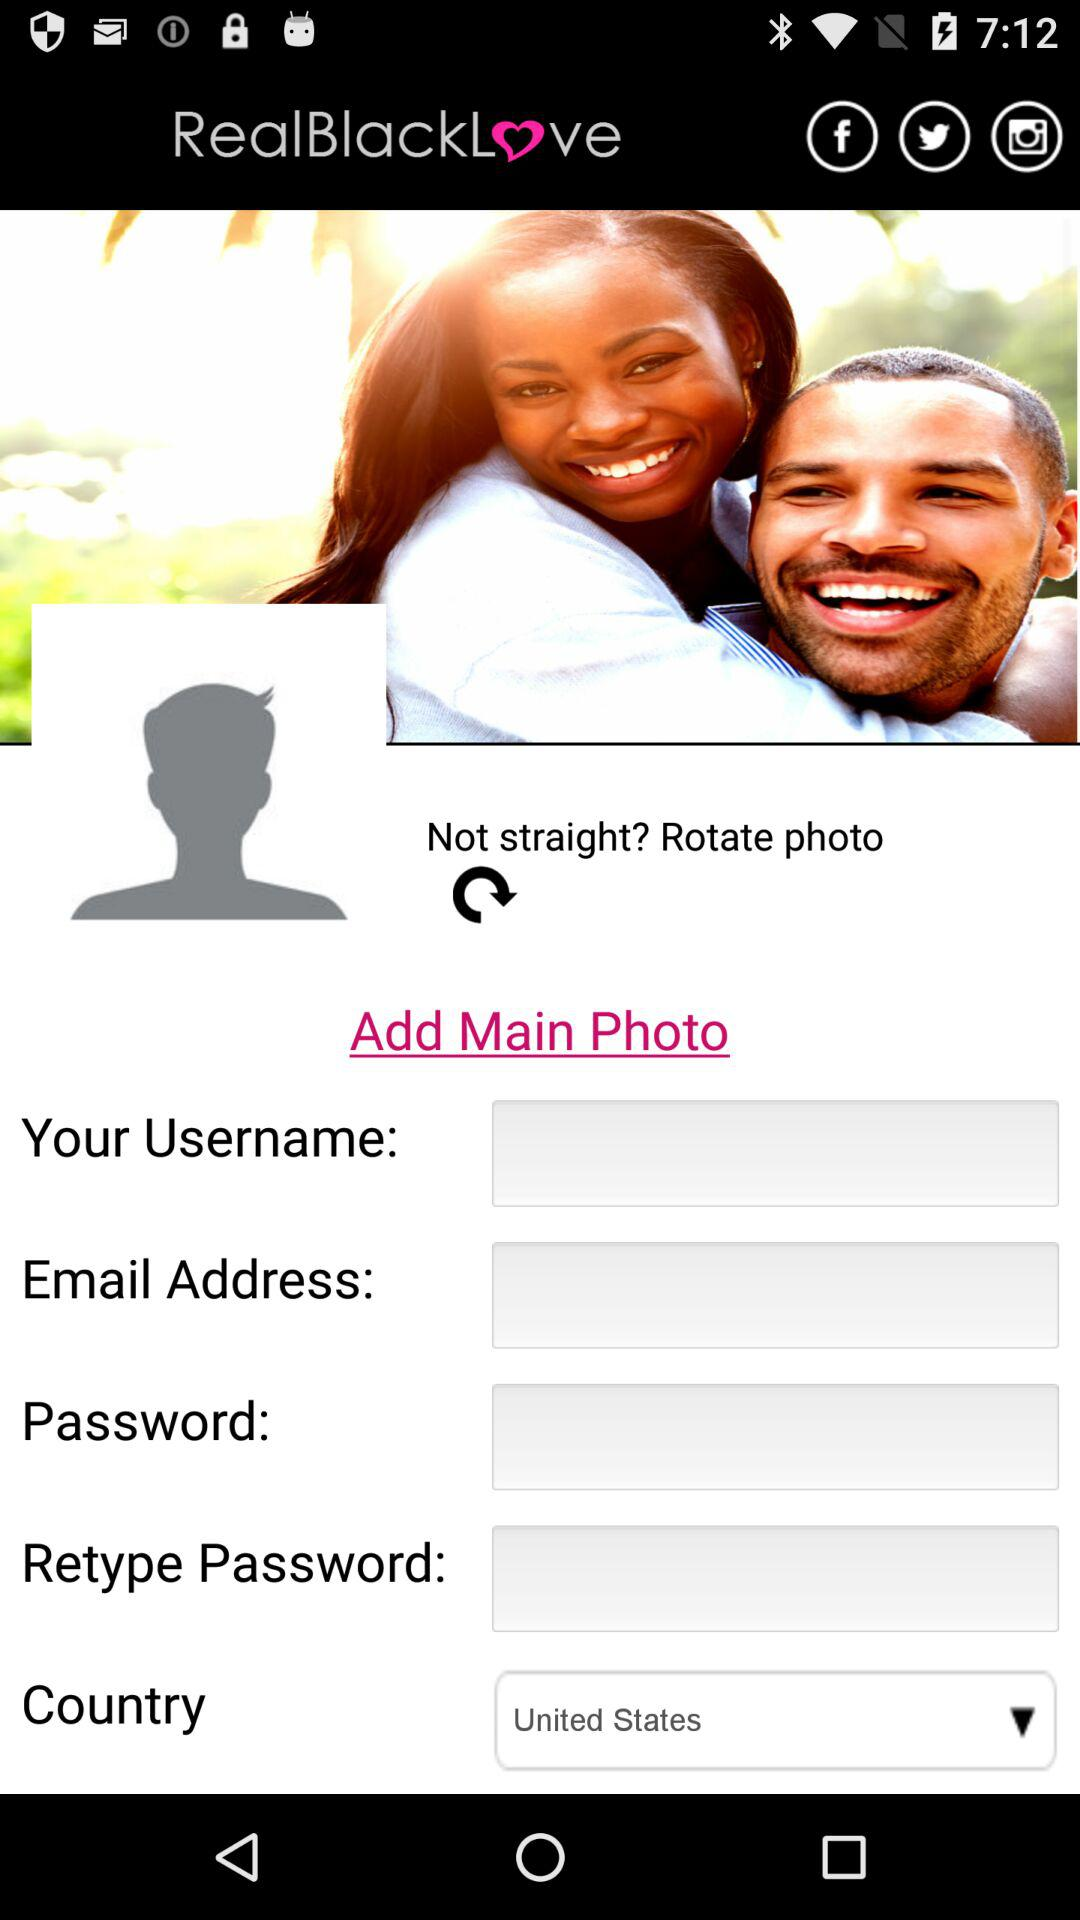What is the entered password?
When the provided information is insufficient, respond with <no answer>. <no answer> 